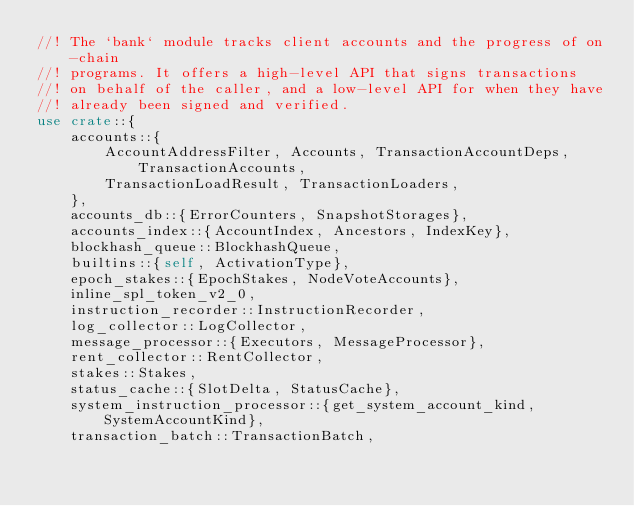Convert code to text. <code><loc_0><loc_0><loc_500><loc_500><_Rust_>//! The `bank` module tracks client accounts and the progress of on-chain
//! programs. It offers a high-level API that signs transactions
//! on behalf of the caller, and a low-level API for when they have
//! already been signed and verified.
use crate::{
    accounts::{
        AccountAddressFilter, Accounts, TransactionAccountDeps, TransactionAccounts,
        TransactionLoadResult, TransactionLoaders,
    },
    accounts_db::{ErrorCounters, SnapshotStorages},
    accounts_index::{AccountIndex, Ancestors, IndexKey},
    blockhash_queue::BlockhashQueue,
    builtins::{self, ActivationType},
    epoch_stakes::{EpochStakes, NodeVoteAccounts},
    inline_spl_token_v2_0,
    instruction_recorder::InstructionRecorder,
    log_collector::LogCollector,
    message_processor::{Executors, MessageProcessor},
    rent_collector::RentCollector,
    stakes::Stakes,
    status_cache::{SlotDelta, StatusCache},
    system_instruction_processor::{get_system_account_kind, SystemAccountKind},
    transaction_batch::TransactionBatch,</code> 